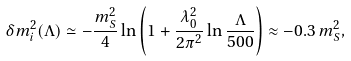<formula> <loc_0><loc_0><loc_500><loc_500>\delta m _ { i } ^ { 2 } ( \Lambda ) \simeq - \frac { m _ { S } ^ { 2 } } { 4 } \ln \left ( 1 + \frac { \lambda _ { 0 } ^ { 2 } } { 2 \pi ^ { 2 } } \ln \frac { \Lambda } { 5 0 0 } \right ) \approx - 0 . 3 \, m _ { S } ^ { 2 } ,</formula> 